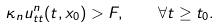<formula> <loc_0><loc_0><loc_500><loc_500>\kappa _ { n } u ^ { n } _ { t t } ( t , x _ { 0 } ) > F , \quad \forall t \geq t _ { 0 } .</formula> 